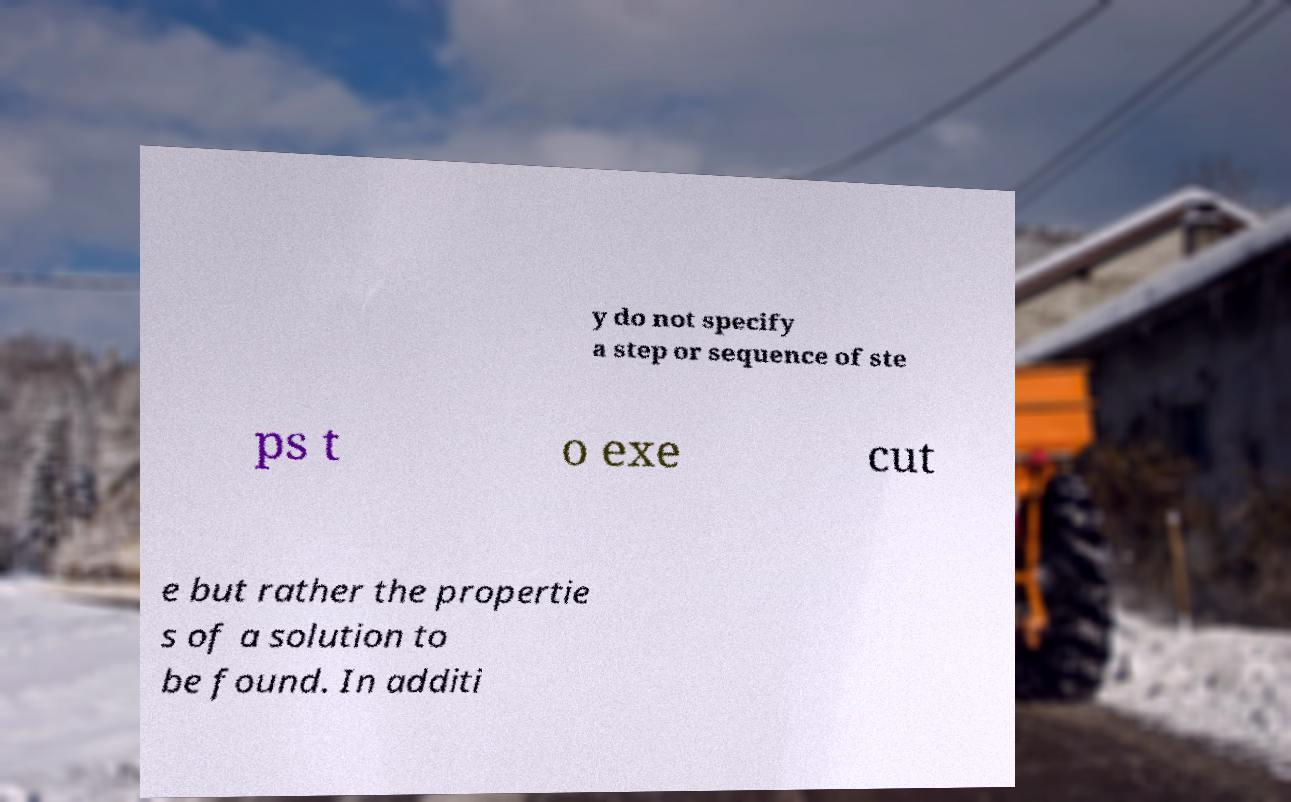Could you extract and type out the text from this image? y do not specify a step or sequence of ste ps t o exe cut e but rather the propertie s of a solution to be found. In additi 